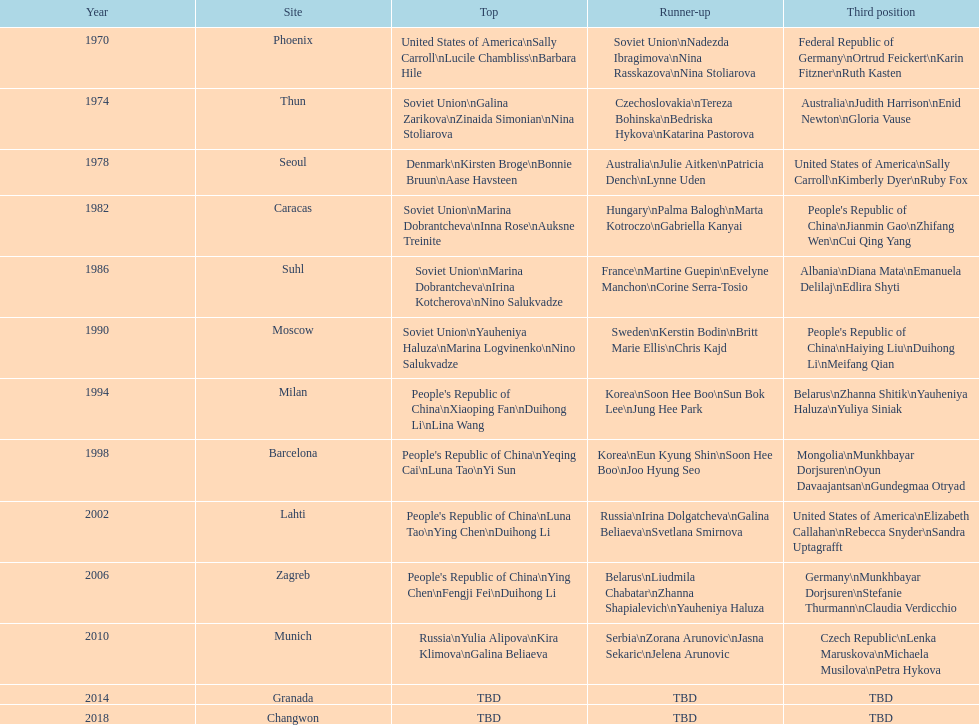Name one of the top three women to earn gold at the 1970 world championship held in phoenix, az Sally Carroll. Give me the full table as a dictionary. {'header': ['Year', 'Site', 'Top', 'Runner-up', 'Third position'], 'rows': [['1970', 'Phoenix', 'United States of America\\nSally Carroll\\nLucile Chambliss\\nBarbara Hile', 'Soviet Union\\nNadezda Ibragimova\\nNina Rasskazova\\nNina Stoliarova', 'Federal Republic of Germany\\nOrtrud Feickert\\nKarin Fitzner\\nRuth Kasten'], ['1974', 'Thun', 'Soviet Union\\nGalina Zarikova\\nZinaida Simonian\\nNina Stoliarova', 'Czechoslovakia\\nTereza Bohinska\\nBedriska Hykova\\nKatarina Pastorova', 'Australia\\nJudith Harrison\\nEnid Newton\\nGloria Vause'], ['1978', 'Seoul', 'Denmark\\nKirsten Broge\\nBonnie Bruun\\nAase Havsteen', 'Australia\\nJulie Aitken\\nPatricia Dench\\nLynne Uden', 'United States of America\\nSally Carroll\\nKimberly Dyer\\nRuby Fox'], ['1982', 'Caracas', 'Soviet Union\\nMarina Dobrantcheva\\nInna Rose\\nAuksne Treinite', 'Hungary\\nPalma Balogh\\nMarta Kotroczo\\nGabriella Kanyai', "People's Republic of China\\nJianmin Gao\\nZhifang Wen\\nCui Qing Yang"], ['1986', 'Suhl', 'Soviet Union\\nMarina Dobrantcheva\\nIrina Kotcherova\\nNino Salukvadze', 'France\\nMartine Guepin\\nEvelyne Manchon\\nCorine Serra-Tosio', 'Albania\\nDiana Mata\\nEmanuela Delilaj\\nEdlira Shyti'], ['1990', 'Moscow', 'Soviet Union\\nYauheniya Haluza\\nMarina Logvinenko\\nNino Salukvadze', 'Sweden\\nKerstin Bodin\\nBritt Marie Ellis\\nChris Kajd', "People's Republic of China\\nHaiying Liu\\nDuihong Li\\nMeifang Qian"], ['1994', 'Milan', "People's Republic of China\\nXiaoping Fan\\nDuihong Li\\nLina Wang", 'Korea\\nSoon Hee Boo\\nSun Bok Lee\\nJung Hee Park', 'Belarus\\nZhanna Shitik\\nYauheniya Haluza\\nYuliya Siniak'], ['1998', 'Barcelona', "People's Republic of China\\nYeqing Cai\\nLuna Tao\\nYi Sun", 'Korea\\nEun Kyung Shin\\nSoon Hee Boo\\nJoo Hyung Seo', 'Mongolia\\nMunkhbayar Dorjsuren\\nOyun Davaajantsan\\nGundegmaa Otryad'], ['2002', 'Lahti', "People's Republic of China\\nLuna Tao\\nYing Chen\\nDuihong Li", 'Russia\\nIrina Dolgatcheva\\nGalina Beliaeva\\nSvetlana Smirnova', 'United States of America\\nElizabeth Callahan\\nRebecca Snyder\\nSandra Uptagrafft'], ['2006', 'Zagreb', "People's Republic of China\\nYing Chen\\nFengji Fei\\nDuihong Li", 'Belarus\\nLiudmila Chabatar\\nZhanna Shapialevich\\nYauheniya Haluza', 'Germany\\nMunkhbayar Dorjsuren\\nStefanie Thurmann\\nClaudia Verdicchio'], ['2010', 'Munich', 'Russia\\nYulia Alipova\\nKira Klimova\\nGalina Beliaeva', 'Serbia\\nZorana Arunovic\\nJasna Sekaric\\nJelena Arunovic', 'Czech Republic\\nLenka Maruskova\\nMichaela Musilova\\nPetra Hykova'], ['2014', 'Granada', 'TBD', 'TBD', 'TBD'], ['2018', 'Changwon', 'TBD', 'TBD', 'TBD']]} 